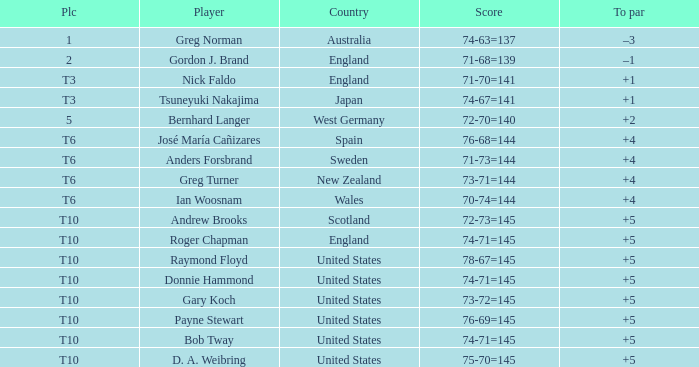What country did Raymond Floyd play for? United States. 